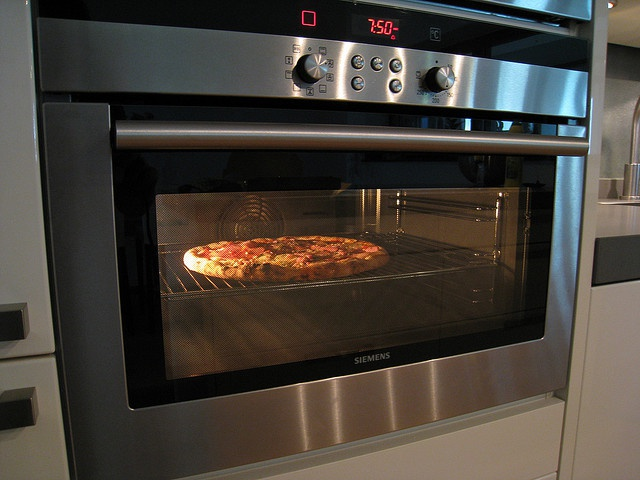Describe the objects in this image and their specific colors. I can see oven in black, gray, and maroon tones and pizza in gray, maroon, brown, orange, and red tones in this image. 